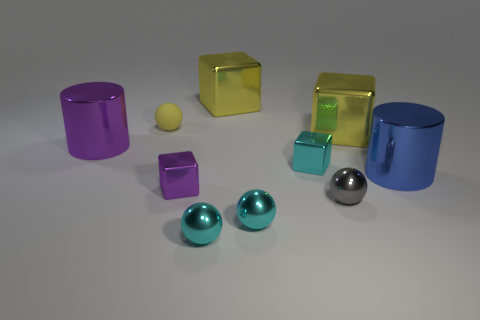Are there the same number of large blue objects that are in front of the tiny purple cube and cylinders in front of the large blue cylinder?
Your answer should be compact. Yes. How many other things are there of the same size as the yellow matte sphere?
Give a very brief answer. 5. What is the size of the gray ball?
Keep it short and to the point. Small. Do the blue object and the tiny cube that is behind the blue metallic object have the same material?
Make the answer very short. Yes. Are there any small purple things that have the same shape as the tiny yellow matte thing?
Your answer should be very brief. No. There is a cyan block that is the same size as the gray sphere; what material is it?
Provide a short and direct response. Metal. There is a yellow block that is behind the yellow ball; what size is it?
Give a very brief answer. Large. Does the sphere that is behind the tiny purple metallic cube have the same size as the cyan block that is behind the tiny purple cube?
Your response must be concise. Yes. What number of other large blue things are made of the same material as the big blue thing?
Your answer should be compact. 0. What is the color of the tiny rubber object?
Keep it short and to the point. Yellow. 